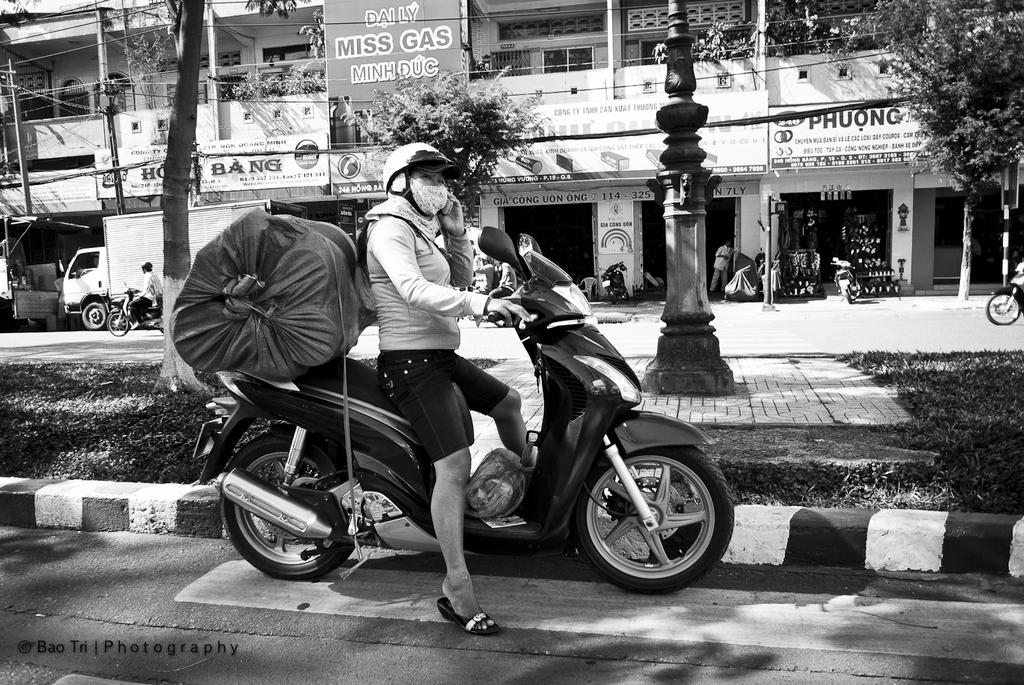Who is the main subject in the image? There is a woman in the image. What is the woman doing in the image? The woman is riding a bike. What is the woman carrying with her while riding the bike? The woman has luggage behind her. What can be seen in the background of the image? There are shops and vehicles on the road in the background of the image. What type of chalk can be seen in the woman's hand while riding the bike? There is no chalk present in the image; the woman is riding a bike with luggage behind her. 